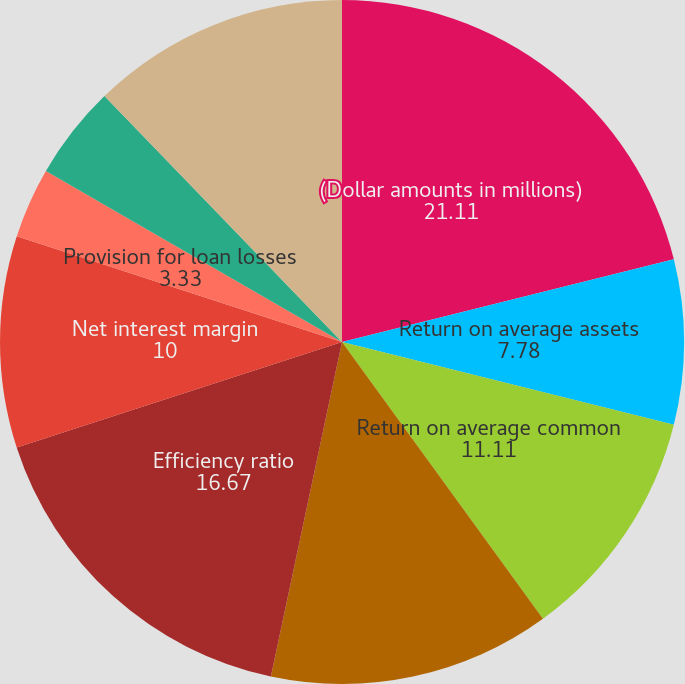Convert chart. <chart><loc_0><loc_0><loc_500><loc_500><pie_chart><fcel>(Dollar amounts in millions)<fcel>Return on average assets<fcel>Return on average common<fcel>Tangible return on average<fcel>Efficiency ratio<fcel>Net interest margin<fcel>Provision for loan losses<fcel>Net loan and lease charge-offs<fcel>Ratio of net charge-offs to<fcel>Allowance for loan losses<nl><fcel>21.11%<fcel>7.78%<fcel>11.11%<fcel>13.33%<fcel>16.67%<fcel>10.0%<fcel>3.33%<fcel>4.44%<fcel>0.0%<fcel>12.22%<nl></chart> 